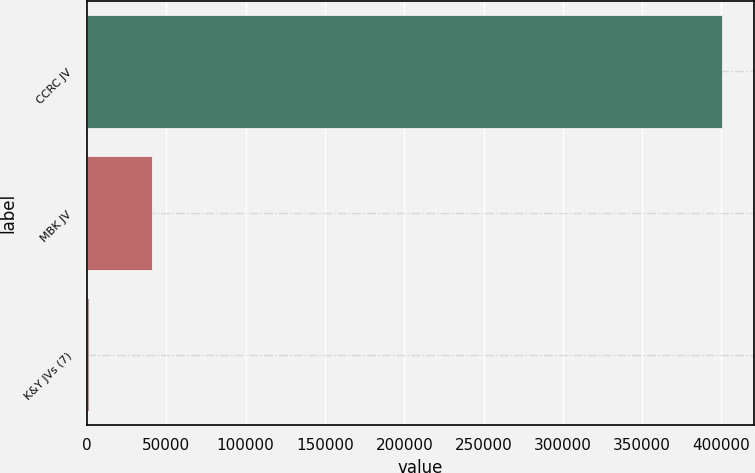<chart> <loc_0><loc_0><loc_500><loc_500><bar_chart><fcel>CCRC JV<fcel>MBK JV<fcel>K&Y JVs (7)<nl><fcel>400241<fcel>41178.8<fcel>1283<nl></chart> 